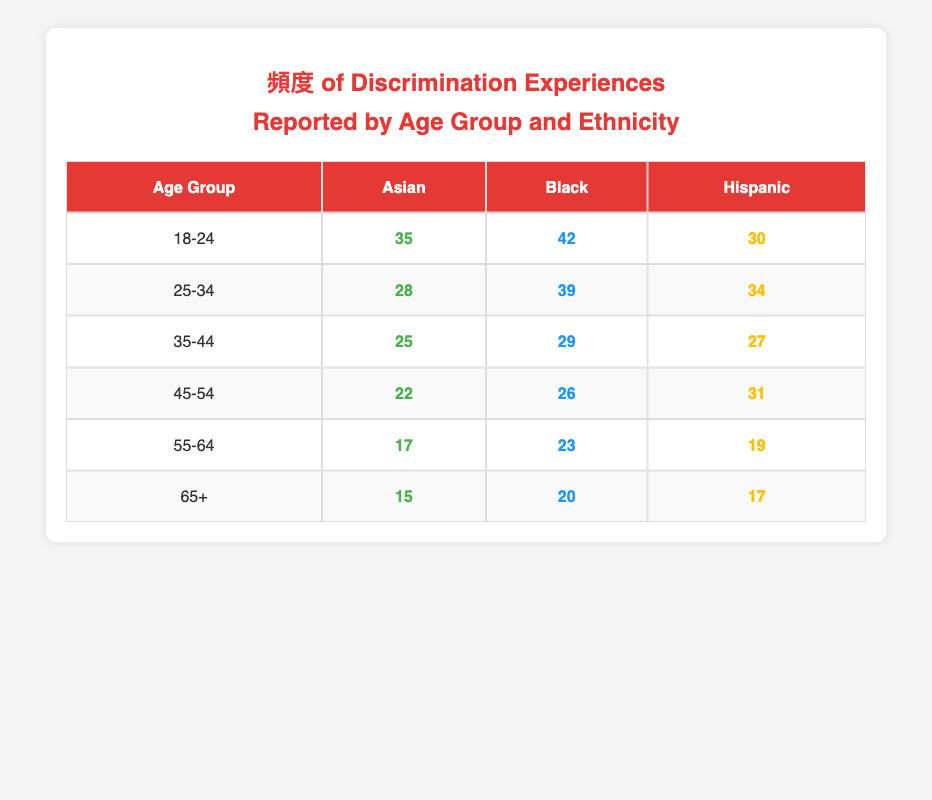What is the frequency of discrimination experiences reported by Hispanic individuals in the 25-34 age group? According to the table, the frequency of discrimination experiences reported by Hispanic individuals in the 25-34 age group is listed directly in the table under that row, which shows a frequency of 34.
Answer: 34 Which age group has the highest frequency of reported discrimination experiences among Black individuals? By comparing the values in the Black column across all age groups, the highest frequency is found in the 18-24 age group with a frequency of 42, which is greater than any other row.
Answer: 42 What is the average frequency of reported discrimination experiences for Asian individuals across all age groups? To calculate the average, we sum the frequencies for Asian individuals: 35 (18-24) + 28 (25-34) + 25 (35-44) + 22 (45-54) + 17 (55-64) + 15 (65+) = 142. There are 6 age groups, so the average is 142 / 6 = 23.67.
Answer: 23.67 Is the frequency of discrimination reported by individuals aged 55-64 higher for Black individuals than for Hispanic individuals? The frequencies for the 55-64 age group are 23 for Black individuals and 19 for Hispanic individuals. Since 23 is greater than 19, the statement is true.
Answer: Yes How many total experiences of discrimination were reported by individuals aged 45-54 across all ethnicities? We add the reported frequencies for the 45-54 age group from all ethnicities: 22 (Asian) + 26 (Black) + 31 (Hispanic) = 79.
Answer: 79 Which ethnicity has the lowest frequency of reported discrimination experiences in the 65+ age group? By comparing the frequencies in the 65+ age group, we see 15 for Asian, 20 for Black, and 17 for Hispanic. Hence, Asian individuals report the lowest frequency at 15.
Answer: Asian What is the difference in reported discrimination experiences between the oldest age group (65+) and the youngest age group (18-24) for Black individuals? The frequency for Black individuals in the 18-24 age group is 42, while in the 65+ age group it is 20. The difference is calculated as 42 - 20 = 22.
Answer: 22 Which age group has reported the least overall frequency of discrimination experiences across all ethnicities? We can sum the reported frequencies by age group: 18-24 = 107, 25-34 = 101, 35-44 = 81, 45-54 = 79, 55-64 = 59, and 65+ = 52. The least is found in the 65+ age group with a total frequency of 52.
Answer: 65+ 